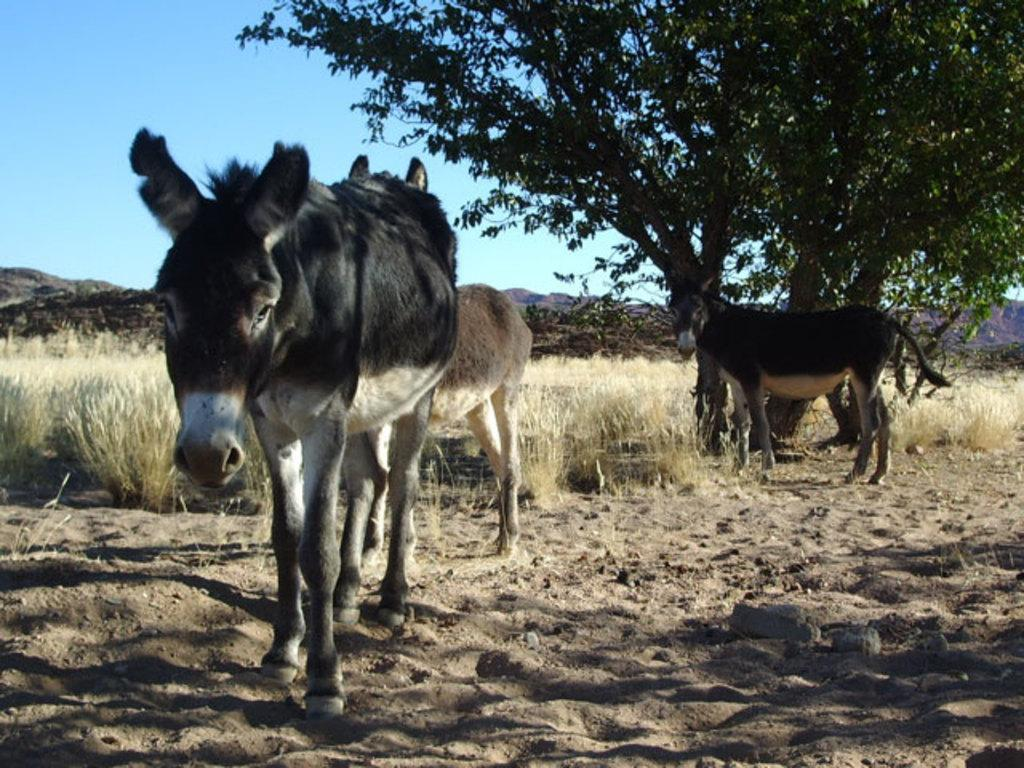What animals can be seen on the ground in the image? There are horses on the ground in the image. What type of vegetation is visible in the image? There are plants and a tree visible in the image. What geographical feature can be seen in the background of the image? The hills are visible in the image. What is the weather like in the image? The sky is cloudy in the image. How many feathers can be seen on the horses in the image? There are no feathers visible on the horses in the image. What type of trail can be seen in the image? There is no trail visible in the image. 